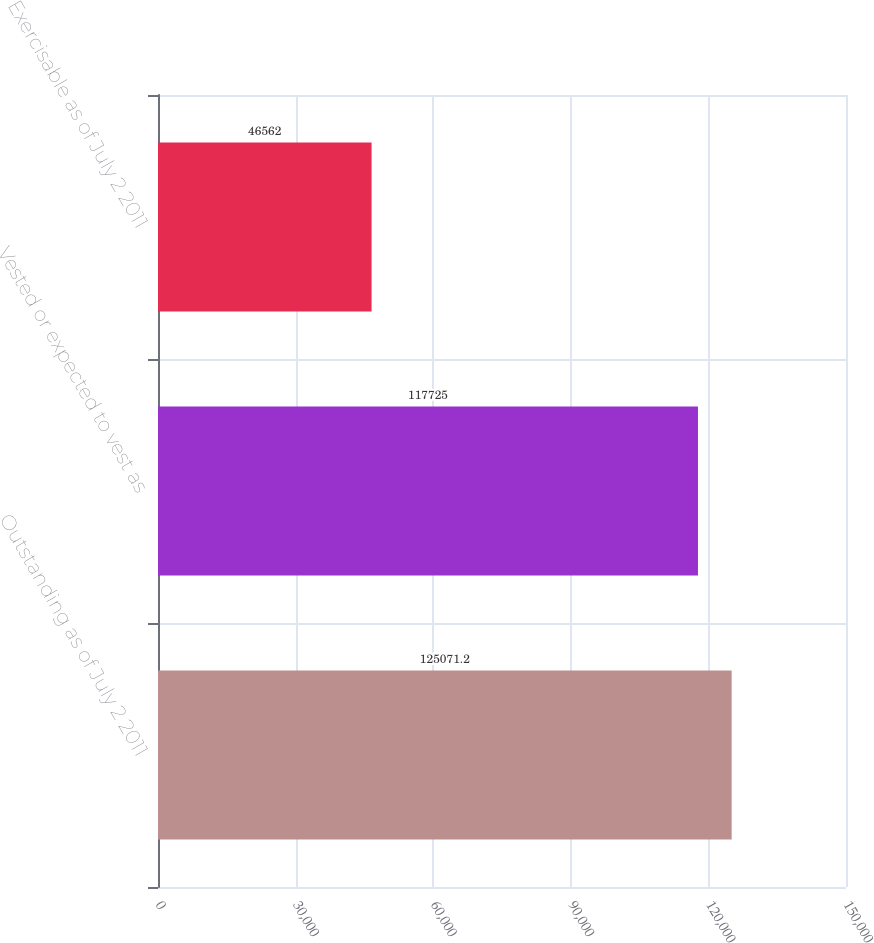<chart> <loc_0><loc_0><loc_500><loc_500><bar_chart><fcel>Outstanding as of July 2 2011<fcel>Vested or expected to vest as<fcel>Exercisable as of July 2 2011<nl><fcel>125071<fcel>117725<fcel>46562<nl></chart> 